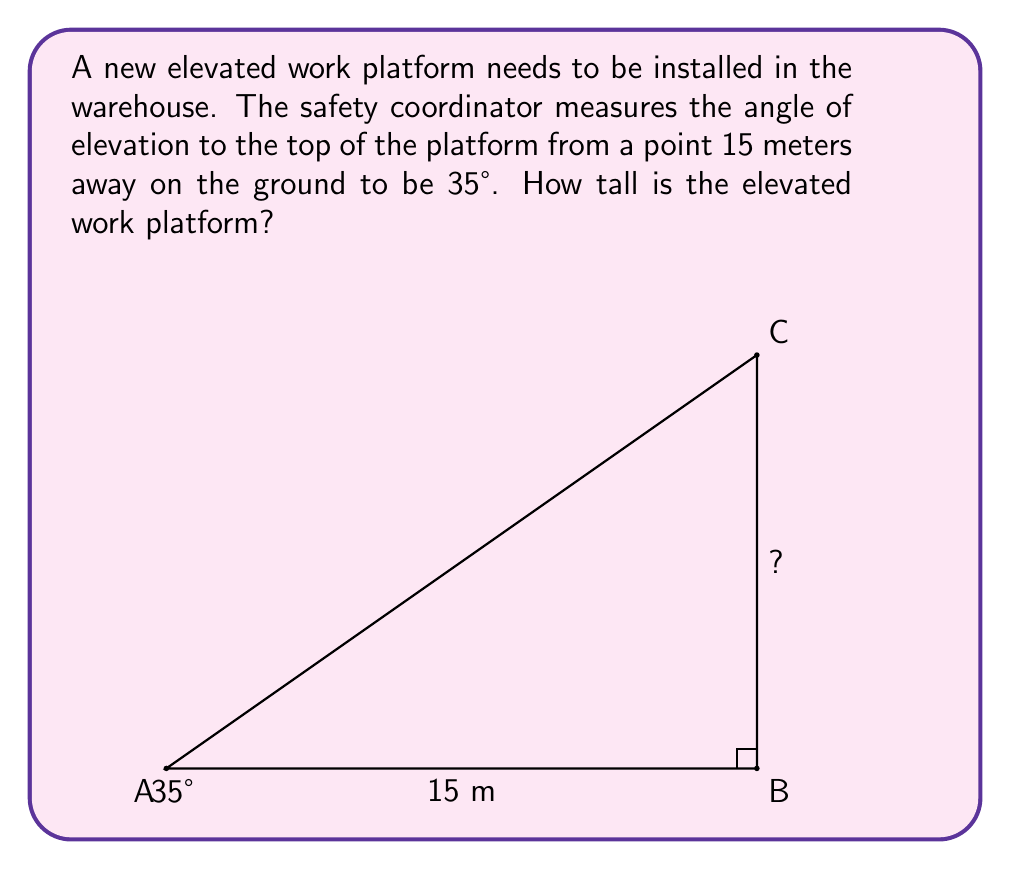Give your solution to this math problem. Let's approach this step-by-step using trigonometry:

1) In this problem, we have a right-angled triangle. We know:
   - The adjacent side (distance from the observer to the base of the platform) = 15 meters
   - The angle of elevation = 35°
   - We need to find the opposite side (height of the platform)

2) The trigonometric ratio that relates the opposite side to the adjacent side is the tangent (tan).

3) The formula for tangent is:

   $$\tan(\theta) = \frac{\text{opposite}}{\text{adjacent}}$$

4) Let's plug in what we know:

   $$\tan(35°) = \frac{\text{height}}{15}$$

5) To solve for height, we multiply both sides by 15:

   $$15 \cdot \tan(35°) = \text{height}$$

6) Now we can calculate:
   
   $$\text{height} = 15 \cdot \tan(35°) \approx 15 \cdot 0.7002 \approx 10.503 \text{ meters}$$

7) Rounding to two decimal places for practical purposes:

   $$\text{height} \approx 10.50 \text{ meters}$$

Thus, the elevated work platform is approximately 10.50 meters tall.
Answer: 10.50 m 